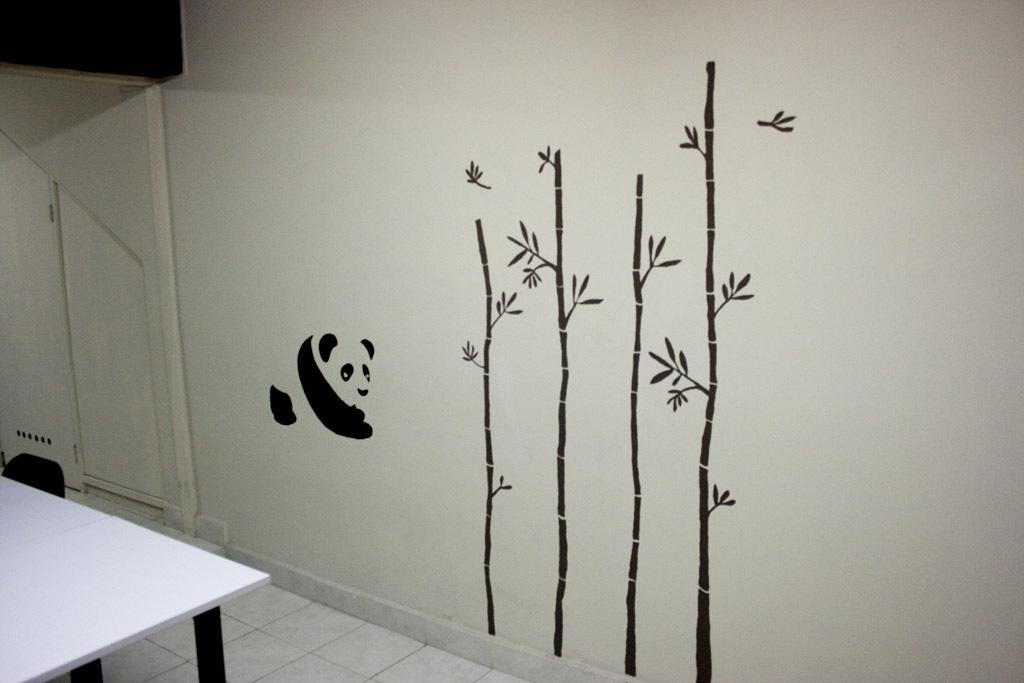What is present on the wall in the image? There are stickers on the wall in the image. What type of furniture can be seen in the image? There is a chair and a table in the image. Where is the airport located in the image? There is no airport present in the image. What type of fight is taking place in the image? There is no fight present in the image. 